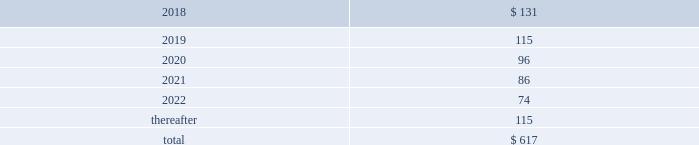13 .
Rentals and leases the company leases sales and administrative office facilities , distribution centers , research and manufacturing facilities , as well as vehicles and other equipment under operating leases .
Total rental expense under the company 2019s operating leases was $ 239 million in 2017 and $ 221 million in both 2016 and 2015 .
As of december 31 , 2017 , identifiable future minimum payments with non-cancelable terms in excess of one year were : ( millions ) .
The company enters into operating leases for vehicles whose non-cancelable terms are one year or less in duration with month-to-month renewal options .
These leases have been excluded from the table above .
The company estimates payments under such leases will approximate $ 62 million in 2018 .
These vehicle leases have guaranteed residual values that have historically been satisfied by the proceeds on the sale of the vehicles .
14 .
Research and development expenditures research expenditures that relate to the development of new products and processes , including significant improvements and refinements to existing products , are expensed as incurred .
Such costs were $ 201 million in 2017 , $ 189 million in 2016 and $ 191 million in 2015 .
The company did not participate in any material customer sponsored research during 2017 , 2016 or 2015 .
15 .
Commitments and contingencies the company is subject to various claims and contingencies related to , among other things , workers 2019 compensation , general liability ( including product liability ) , automobile claims , health care claims , environmental matters and lawsuits .
The company is also subject to various claims and contingencies related to income taxes , which are discussed in note 12 .
The company also has contractual obligations including lease commitments , which are discussed in note 13 .
The company records liabilities where a contingent loss is probable and can be reasonably estimated .
If the reasonable estimate of a probable loss is a range , the company records the most probable estimate of the loss or the minimum amount when no amount within the range is a better estimate than any other amount .
The company discloses a contingent liability even if the liability is not probable or the amount is not estimable , or both , if there is a reasonable possibility that a material loss may have been incurred .
Insurance globally , the company has insurance policies with varying deductibility levels for property and casualty losses .
The company is insured for losses in excess of these deductibles , subject to policy terms and conditions and has recorded both a liability and an offsetting receivable for amounts in excess of these deductibles .
The company is self-insured for health care claims for eligible participating employees , subject to certain deductibles and limitations .
The company determines its liabilities for claims on an actuarial basis .
Litigation and environmental matters the company and certain subsidiaries are party to various lawsuits , claims and environmental actions that have arisen in the ordinary course of business .
These include from time to time antitrust , commercial , patent infringement , product liability and wage hour lawsuits , as well as possible obligations to investigate and mitigate the effects on the environment of the disposal or release of certain chemical substances at various sites , such as superfund sites and other operating or closed facilities .
The company has established accruals for certain lawsuits , claims and environmental matters .
The company currently believes that there is not a reasonably possible risk of material loss in excess of the amounts accrued related to these legal matters .
Because litigation is inherently uncertain , and unfavorable rulings or developments could occur , there can be no certainty that the company may not ultimately incur charges in excess of recorded liabilities .
A future adverse ruling , settlement or unfavorable development could result in future charges that could have a material adverse effect on the company 2019s results of operations or cash flows in the period in which they are recorded .
The company currently believes that such future charges related to suits and legal claims , if any , would not have a material adverse effect on the company 2019s consolidated financial position .
Environmental matters the company is currently participating in environmental assessments and remediation at approximately 45 locations , the majority of which are in the u.s. , and environmental liabilities have been accrued reflecting management 2019s best estimate of future costs .
Potential insurance reimbursements are not anticipated in the company 2019s accruals for environmental liabilities. .
What is the percentage change in the r&d expenses from 2015 to 2016? 
Computations: ((189 - 191) / 191)
Answer: -0.01047. 13 .
Rentals and leases the company leases sales and administrative office facilities , distribution centers , research and manufacturing facilities , as well as vehicles and other equipment under operating leases .
Total rental expense under the company 2019s operating leases was $ 239 million in 2017 and $ 221 million in both 2016 and 2015 .
As of december 31 , 2017 , identifiable future minimum payments with non-cancelable terms in excess of one year were : ( millions ) .
The company enters into operating leases for vehicles whose non-cancelable terms are one year or less in duration with month-to-month renewal options .
These leases have been excluded from the table above .
The company estimates payments under such leases will approximate $ 62 million in 2018 .
These vehicle leases have guaranteed residual values that have historically been satisfied by the proceeds on the sale of the vehicles .
14 .
Research and development expenditures research expenditures that relate to the development of new products and processes , including significant improvements and refinements to existing products , are expensed as incurred .
Such costs were $ 201 million in 2017 , $ 189 million in 2016 and $ 191 million in 2015 .
The company did not participate in any material customer sponsored research during 2017 , 2016 or 2015 .
15 .
Commitments and contingencies the company is subject to various claims and contingencies related to , among other things , workers 2019 compensation , general liability ( including product liability ) , automobile claims , health care claims , environmental matters and lawsuits .
The company is also subject to various claims and contingencies related to income taxes , which are discussed in note 12 .
The company also has contractual obligations including lease commitments , which are discussed in note 13 .
The company records liabilities where a contingent loss is probable and can be reasonably estimated .
If the reasonable estimate of a probable loss is a range , the company records the most probable estimate of the loss or the minimum amount when no amount within the range is a better estimate than any other amount .
The company discloses a contingent liability even if the liability is not probable or the amount is not estimable , or both , if there is a reasonable possibility that a material loss may have been incurred .
Insurance globally , the company has insurance policies with varying deductibility levels for property and casualty losses .
The company is insured for losses in excess of these deductibles , subject to policy terms and conditions and has recorded both a liability and an offsetting receivable for amounts in excess of these deductibles .
The company is self-insured for health care claims for eligible participating employees , subject to certain deductibles and limitations .
The company determines its liabilities for claims on an actuarial basis .
Litigation and environmental matters the company and certain subsidiaries are party to various lawsuits , claims and environmental actions that have arisen in the ordinary course of business .
These include from time to time antitrust , commercial , patent infringement , product liability and wage hour lawsuits , as well as possible obligations to investigate and mitigate the effects on the environment of the disposal or release of certain chemical substances at various sites , such as superfund sites and other operating or closed facilities .
The company has established accruals for certain lawsuits , claims and environmental matters .
The company currently believes that there is not a reasonably possible risk of material loss in excess of the amounts accrued related to these legal matters .
Because litigation is inherently uncertain , and unfavorable rulings or developments could occur , there can be no certainty that the company may not ultimately incur charges in excess of recorded liabilities .
A future adverse ruling , settlement or unfavorable development could result in future charges that could have a material adverse effect on the company 2019s results of operations or cash flows in the period in which they are recorded .
The company currently believes that such future charges related to suits and legal claims , if any , would not have a material adverse effect on the company 2019s consolidated financial position .
Environmental matters the company is currently participating in environmental assessments and remediation at approximately 45 locations , the majority of which are in the u.s. , and environmental liabilities have been accrued reflecting management 2019s best estimate of future costs .
Potential insurance reimbursements are not anticipated in the company 2019s accruals for environmental liabilities. .
What is the percentage change in the r&d expenses from 2016 to 2017? 
Computations: ((201 - 189) / 189)
Answer: 0.06349. 13 .
Rentals and leases the company leases sales and administrative office facilities , distribution centers , research and manufacturing facilities , as well as vehicles and other equipment under operating leases .
Total rental expense under the company 2019s operating leases was $ 239 million in 2017 and $ 221 million in both 2016 and 2015 .
As of december 31 , 2017 , identifiable future minimum payments with non-cancelable terms in excess of one year were : ( millions ) .
The company enters into operating leases for vehicles whose non-cancelable terms are one year or less in duration with month-to-month renewal options .
These leases have been excluded from the table above .
The company estimates payments under such leases will approximate $ 62 million in 2018 .
These vehicle leases have guaranteed residual values that have historically been satisfied by the proceeds on the sale of the vehicles .
14 .
Research and development expenditures research expenditures that relate to the development of new products and processes , including significant improvements and refinements to existing products , are expensed as incurred .
Such costs were $ 201 million in 2017 , $ 189 million in 2016 and $ 191 million in 2015 .
The company did not participate in any material customer sponsored research during 2017 , 2016 or 2015 .
15 .
Commitments and contingencies the company is subject to various claims and contingencies related to , among other things , workers 2019 compensation , general liability ( including product liability ) , automobile claims , health care claims , environmental matters and lawsuits .
The company is also subject to various claims and contingencies related to income taxes , which are discussed in note 12 .
The company also has contractual obligations including lease commitments , which are discussed in note 13 .
The company records liabilities where a contingent loss is probable and can be reasonably estimated .
If the reasonable estimate of a probable loss is a range , the company records the most probable estimate of the loss or the minimum amount when no amount within the range is a better estimate than any other amount .
The company discloses a contingent liability even if the liability is not probable or the amount is not estimable , or both , if there is a reasonable possibility that a material loss may have been incurred .
Insurance globally , the company has insurance policies with varying deductibility levels for property and casualty losses .
The company is insured for losses in excess of these deductibles , subject to policy terms and conditions and has recorded both a liability and an offsetting receivable for amounts in excess of these deductibles .
The company is self-insured for health care claims for eligible participating employees , subject to certain deductibles and limitations .
The company determines its liabilities for claims on an actuarial basis .
Litigation and environmental matters the company and certain subsidiaries are party to various lawsuits , claims and environmental actions that have arisen in the ordinary course of business .
These include from time to time antitrust , commercial , patent infringement , product liability and wage hour lawsuits , as well as possible obligations to investigate and mitigate the effects on the environment of the disposal or release of certain chemical substances at various sites , such as superfund sites and other operating or closed facilities .
The company has established accruals for certain lawsuits , claims and environmental matters .
The company currently believes that there is not a reasonably possible risk of material loss in excess of the amounts accrued related to these legal matters .
Because litigation is inherently uncertain , and unfavorable rulings or developments could occur , there can be no certainty that the company may not ultimately incur charges in excess of recorded liabilities .
A future adverse ruling , settlement or unfavorable development could result in future charges that could have a material adverse effect on the company 2019s results of operations or cash flows in the period in which they are recorded .
The company currently believes that such future charges related to suits and legal claims , if any , would not have a material adverse effect on the company 2019s consolidated financial position .
Environmental matters the company is currently participating in environmental assessments and remediation at approximately 45 locations , the majority of which are in the u.s. , and environmental liabilities have been accrued reflecting management 2019s best estimate of future costs .
Potential insurance reimbursements are not anticipated in the company 2019s accruals for environmental liabilities. .
Total rental expense under the company 2019s operating leases changed by how much in millions between 2017 and 2018? 
Computations: (131 - 239)
Answer: -108.0. 